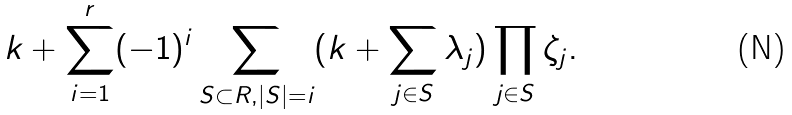Convert formula to latex. <formula><loc_0><loc_0><loc_500><loc_500>k + \sum _ { i = 1 } ^ { r } ( - 1 ) ^ { i } \sum _ { S \subset R , | S | = i } ( k + \sum _ { j \in S } \lambda _ { j } ) \prod _ { j \in S } \zeta _ { j } .</formula> 